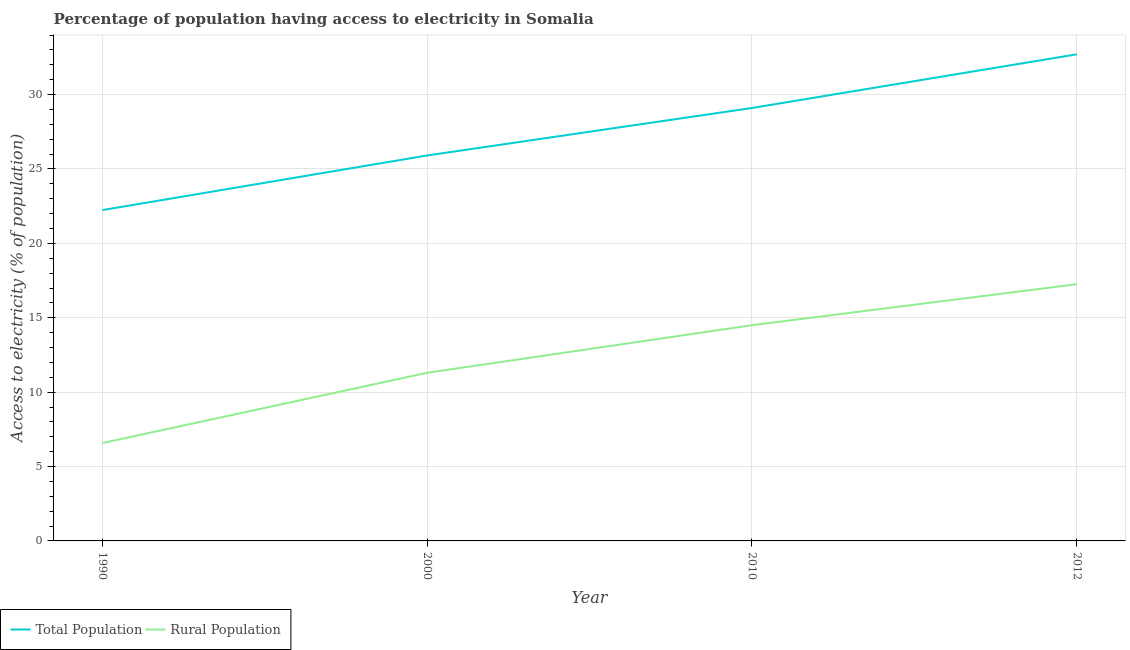How many different coloured lines are there?
Provide a short and direct response. 2. What is the percentage of population having access to electricity in 2012?
Ensure brevity in your answer.  32.71. Across all years, what is the maximum percentage of rural population having access to electricity?
Your answer should be compact. 17.25. Across all years, what is the minimum percentage of population having access to electricity?
Your answer should be very brief. 22.24. In which year was the percentage of rural population having access to electricity maximum?
Provide a succinct answer. 2012. In which year was the percentage of population having access to electricity minimum?
Offer a very short reply. 1990. What is the total percentage of population having access to electricity in the graph?
Give a very brief answer. 109.96. What is the difference between the percentage of population having access to electricity in 2000 and that in 2010?
Give a very brief answer. -3.19. What is the difference between the percentage of population having access to electricity in 2010 and the percentage of rural population having access to electricity in 1990?
Give a very brief answer. 22.52. What is the average percentage of population having access to electricity per year?
Give a very brief answer. 27.49. In the year 2010, what is the difference between the percentage of population having access to electricity and percentage of rural population having access to electricity?
Ensure brevity in your answer.  14.6. What is the ratio of the percentage of population having access to electricity in 1990 to that in 2012?
Provide a succinct answer. 0.68. Is the percentage of population having access to electricity in 1990 less than that in 2000?
Ensure brevity in your answer.  Yes. Is the difference between the percentage of rural population having access to electricity in 2000 and 2012 greater than the difference between the percentage of population having access to electricity in 2000 and 2012?
Offer a terse response. Yes. What is the difference between the highest and the second highest percentage of rural population having access to electricity?
Provide a short and direct response. 2.75. What is the difference between the highest and the lowest percentage of rural population having access to electricity?
Make the answer very short. 10.68. Is the sum of the percentage of population having access to electricity in 2000 and 2010 greater than the maximum percentage of rural population having access to electricity across all years?
Give a very brief answer. Yes. Does the percentage of population having access to electricity monotonically increase over the years?
Provide a succinct answer. Yes. How many lines are there?
Your answer should be very brief. 2. What is the difference between two consecutive major ticks on the Y-axis?
Keep it short and to the point. 5. Are the values on the major ticks of Y-axis written in scientific E-notation?
Give a very brief answer. No. Does the graph contain grids?
Keep it short and to the point. Yes. How many legend labels are there?
Provide a succinct answer. 2. How are the legend labels stacked?
Your answer should be very brief. Horizontal. What is the title of the graph?
Provide a short and direct response. Percentage of population having access to electricity in Somalia. What is the label or title of the Y-axis?
Keep it short and to the point. Access to electricity (% of population). What is the Access to electricity (% of population) in Total Population in 1990?
Your answer should be compact. 22.24. What is the Access to electricity (% of population) in Rural Population in 1990?
Provide a succinct answer. 6.58. What is the Access to electricity (% of population) of Total Population in 2000?
Your answer should be compact. 25.91. What is the Access to electricity (% of population) of Rural Population in 2000?
Give a very brief answer. 11.3. What is the Access to electricity (% of population) in Total Population in 2010?
Offer a very short reply. 29.1. What is the Access to electricity (% of population) in Total Population in 2012?
Make the answer very short. 32.71. What is the Access to electricity (% of population) of Rural Population in 2012?
Provide a succinct answer. 17.25. Across all years, what is the maximum Access to electricity (% of population) in Total Population?
Keep it short and to the point. 32.71. Across all years, what is the maximum Access to electricity (% of population) of Rural Population?
Give a very brief answer. 17.25. Across all years, what is the minimum Access to electricity (% of population) in Total Population?
Offer a terse response. 22.24. Across all years, what is the minimum Access to electricity (% of population) in Rural Population?
Your answer should be compact. 6.58. What is the total Access to electricity (% of population) in Total Population in the graph?
Provide a succinct answer. 109.96. What is the total Access to electricity (% of population) of Rural Population in the graph?
Your answer should be compact. 49.64. What is the difference between the Access to electricity (% of population) of Total Population in 1990 and that in 2000?
Ensure brevity in your answer.  -3.67. What is the difference between the Access to electricity (% of population) of Rural Population in 1990 and that in 2000?
Your answer should be very brief. -4.72. What is the difference between the Access to electricity (% of population) of Total Population in 1990 and that in 2010?
Give a very brief answer. -6.86. What is the difference between the Access to electricity (% of population) in Rural Population in 1990 and that in 2010?
Ensure brevity in your answer.  -7.92. What is the difference between the Access to electricity (% of population) of Total Population in 1990 and that in 2012?
Keep it short and to the point. -10.47. What is the difference between the Access to electricity (% of population) in Rural Population in 1990 and that in 2012?
Your response must be concise. -10.68. What is the difference between the Access to electricity (% of population) in Total Population in 2000 and that in 2010?
Provide a short and direct response. -3.19. What is the difference between the Access to electricity (% of population) of Rural Population in 2000 and that in 2010?
Your answer should be compact. -3.2. What is the difference between the Access to electricity (% of population) of Total Population in 2000 and that in 2012?
Offer a very short reply. -6.8. What is the difference between the Access to electricity (% of population) of Rural Population in 2000 and that in 2012?
Your response must be concise. -5.95. What is the difference between the Access to electricity (% of population) of Total Population in 2010 and that in 2012?
Offer a very short reply. -3.61. What is the difference between the Access to electricity (% of population) of Rural Population in 2010 and that in 2012?
Provide a short and direct response. -2.75. What is the difference between the Access to electricity (% of population) of Total Population in 1990 and the Access to electricity (% of population) of Rural Population in 2000?
Provide a succinct answer. 10.94. What is the difference between the Access to electricity (% of population) of Total Population in 1990 and the Access to electricity (% of population) of Rural Population in 2010?
Offer a very short reply. 7.74. What is the difference between the Access to electricity (% of population) of Total Population in 1990 and the Access to electricity (% of population) of Rural Population in 2012?
Keep it short and to the point. 4.98. What is the difference between the Access to electricity (% of population) of Total Population in 2000 and the Access to electricity (% of population) of Rural Population in 2010?
Your response must be concise. 11.41. What is the difference between the Access to electricity (% of population) of Total Population in 2000 and the Access to electricity (% of population) of Rural Population in 2012?
Offer a terse response. 8.65. What is the difference between the Access to electricity (% of population) in Total Population in 2010 and the Access to electricity (% of population) in Rural Population in 2012?
Your answer should be compact. 11.85. What is the average Access to electricity (% of population) in Total Population per year?
Offer a terse response. 27.49. What is the average Access to electricity (% of population) in Rural Population per year?
Ensure brevity in your answer.  12.41. In the year 1990, what is the difference between the Access to electricity (% of population) of Total Population and Access to electricity (% of population) of Rural Population?
Provide a succinct answer. 15.66. In the year 2000, what is the difference between the Access to electricity (% of population) of Total Population and Access to electricity (% of population) of Rural Population?
Your answer should be compact. 14.61. In the year 2012, what is the difference between the Access to electricity (% of population) in Total Population and Access to electricity (% of population) in Rural Population?
Your answer should be very brief. 15.45. What is the ratio of the Access to electricity (% of population) in Total Population in 1990 to that in 2000?
Offer a terse response. 0.86. What is the ratio of the Access to electricity (% of population) in Rural Population in 1990 to that in 2000?
Your answer should be very brief. 0.58. What is the ratio of the Access to electricity (% of population) in Total Population in 1990 to that in 2010?
Provide a short and direct response. 0.76. What is the ratio of the Access to electricity (% of population) in Rural Population in 1990 to that in 2010?
Your answer should be very brief. 0.45. What is the ratio of the Access to electricity (% of population) in Total Population in 1990 to that in 2012?
Ensure brevity in your answer.  0.68. What is the ratio of the Access to electricity (% of population) of Rural Population in 1990 to that in 2012?
Provide a succinct answer. 0.38. What is the ratio of the Access to electricity (% of population) of Total Population in 2000 to that in 2010?
Your answer should be compact. 0.89. What is the ratio of the Access to electricity (% of population) of Rural Population in 2000 to that in 2010?
Offer a terse response. 0.78. What is the ratio of the Access to electricity (% of population) of Total Population in 2000 to that in 2012?
Keep it short and to the point. 0.79. What is the ratio of the Access to electricity (% of population) in Rural Population in 2000 to that in 2012?
Give a very brief answer. 0.66. What is the ratio of the Access to electricity (% of population) in Total Population in 2010 to that in 2012?
Provide a short and direct response. 0.89. What is the ratio of the Access to electricity (% of population) of Rural Population in 2010 to that in 2012?
Make the answer very short. 0.84. What is the difference between the highest and the second highest Access to electricity (% of population) in Total Population?
Your response must be concise. 3.61. What is the difference between the highest and the second highest Access to electricity (% of population) of Rural Population?
Your response must be concise. 2.75. What is the difference between the highest and the lowest Access to electricity (% of population) in Total Population?
Provide a short and direct response. 10.47. What is the difference between the highest and the lowest Access to electricity (% of population) of Rural Population?
Your answer should be very brief. 10.68. 